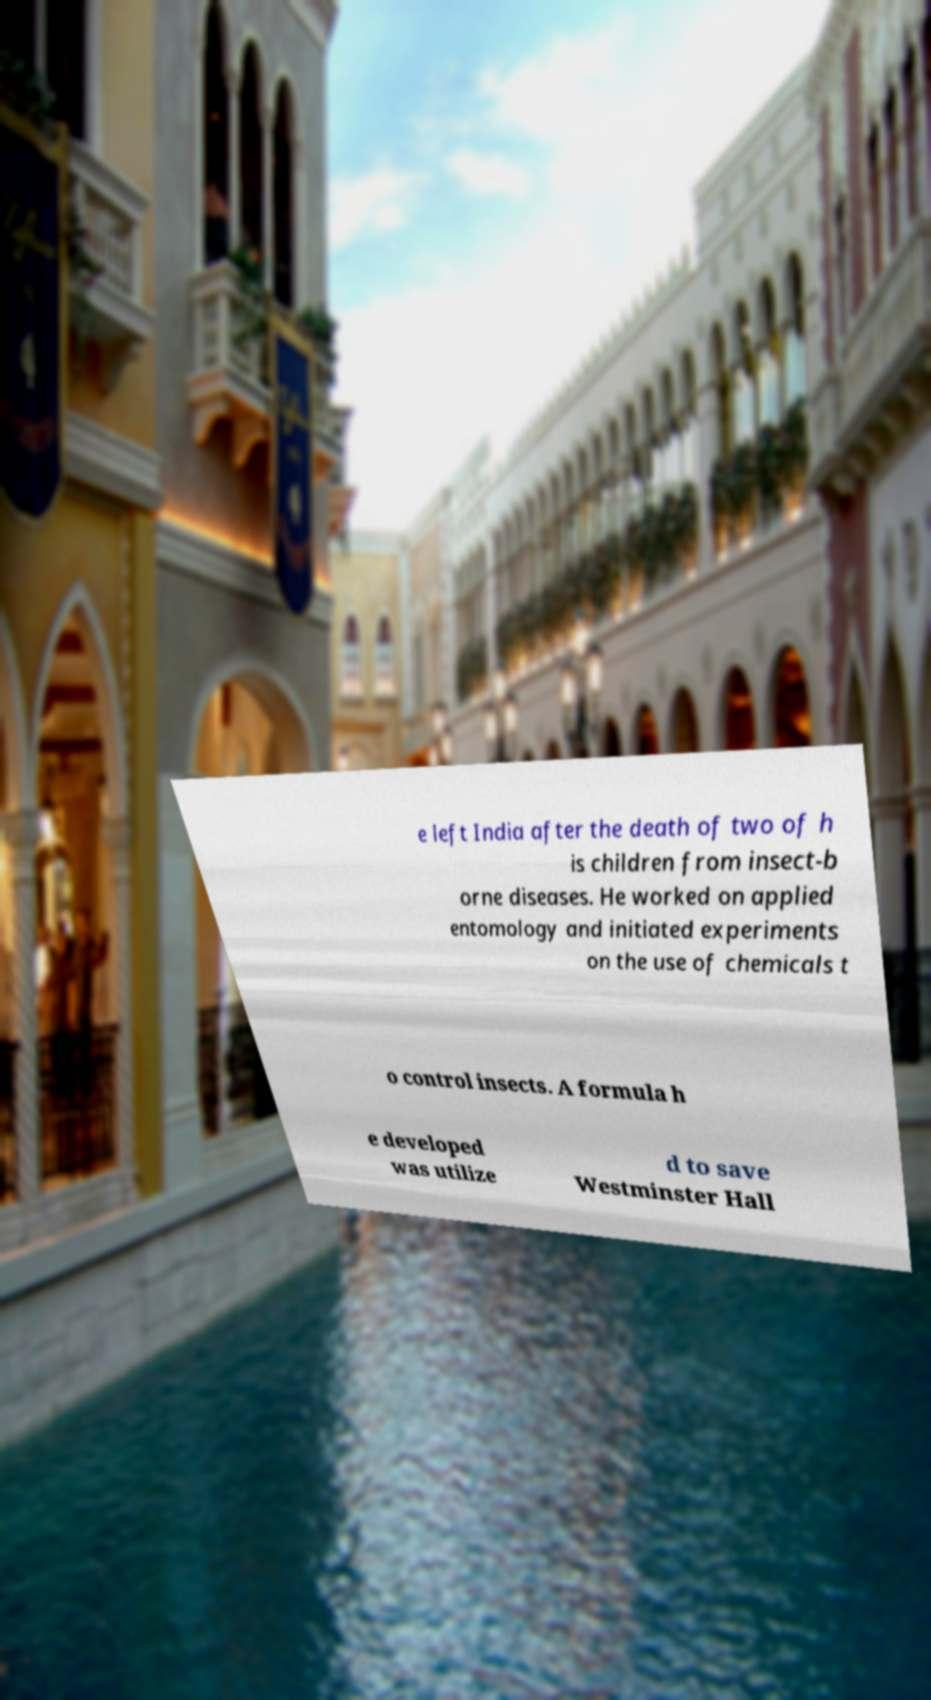Can you accurately transcribe the text from the provided image for me? e left India after the death of two of h is children from insect-b orne diseases. He worked on applied entomology and initiated experiments on the use of chemicals t o control insects. A formula h e developed was utilize d to save Westminster Hall 